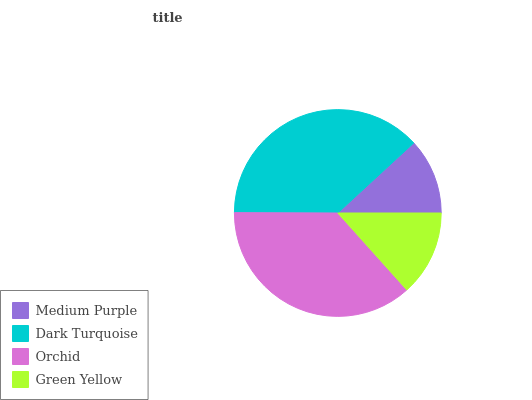Is Medium Purple the minimum?
Answer yes or no. Yes. Is Dark Turquoise the maximum?
Answer yes or no. Yes. Is Orchid the minimum?
Answer yes or no. No. Is Orchid the maximum?
Answer yes or no. No. Is Dark Turquoise greater than Orchid?
Answer yes or no. Yes. Is Orchid less than Dark Turquoise?
Answer yes or no. Yes. Is Orchid greater than Dark Turquoise?
Answer yes or no. No. Is Dark Turquoise less than Orchid?
Answer yes or no. No. Is Orchid the high median?
Answer yes or no. Yes. Is Green Yellow the low median?
Answer yes or no. Yes. Is Green Yellow the high median?
Answer yes or no. No. Is Medium Purple the low median?
Answer yes or no. No. 